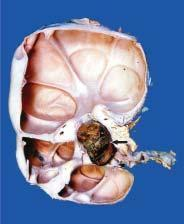s the kidney enlarged and heavy?
Answer the question using a single word or phrase. Yes 